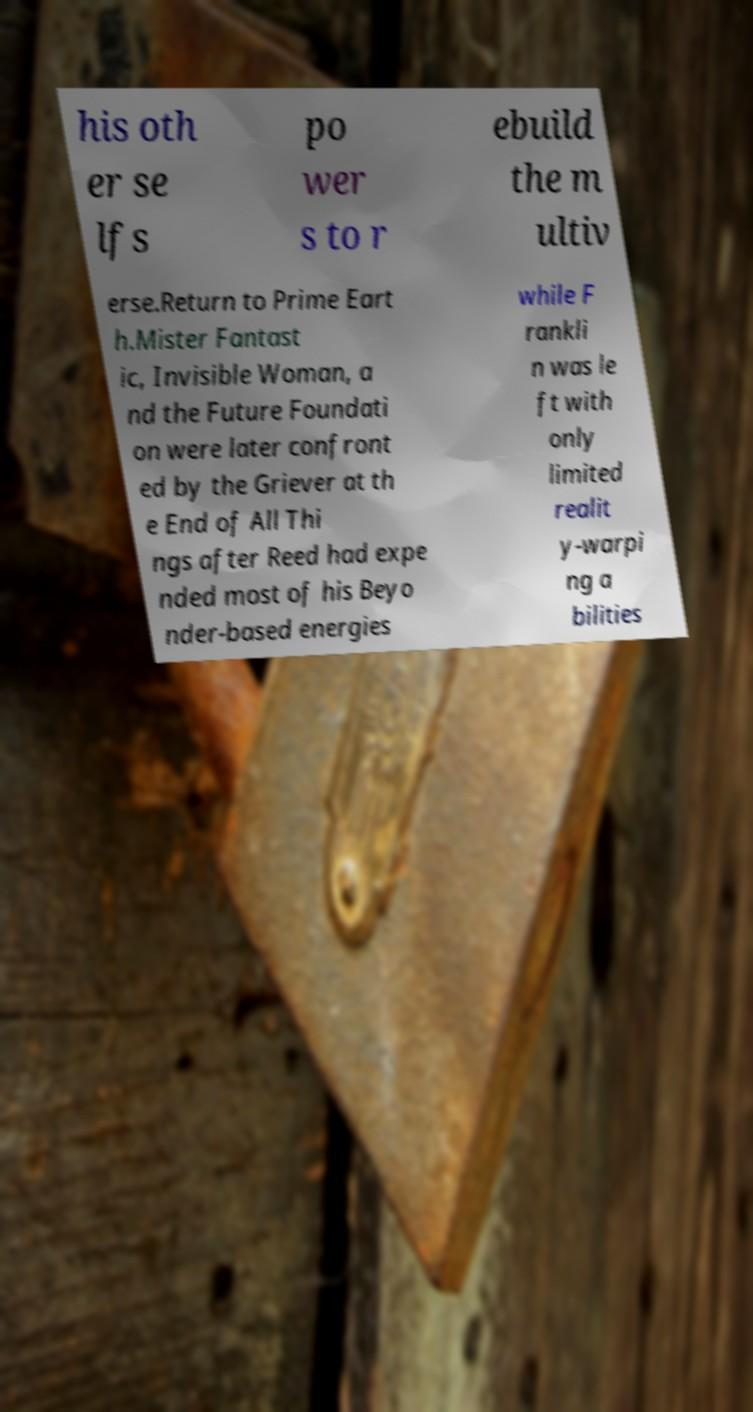Please read and relay the text visible in this image. What does it say? his oth er se lfs po wer s to r ebuild the m ultiv erse.Return to Prime Eart h.Mister Fantast ic, Invisible Woman, a nd the Future Foundati on were later confront ed by the Griever at th e End of All Thi ngs after Reed had expe nded most of his Beyo nder-based energies while F rankli n was le ft with only limited realit y-warpi ng a bilities 